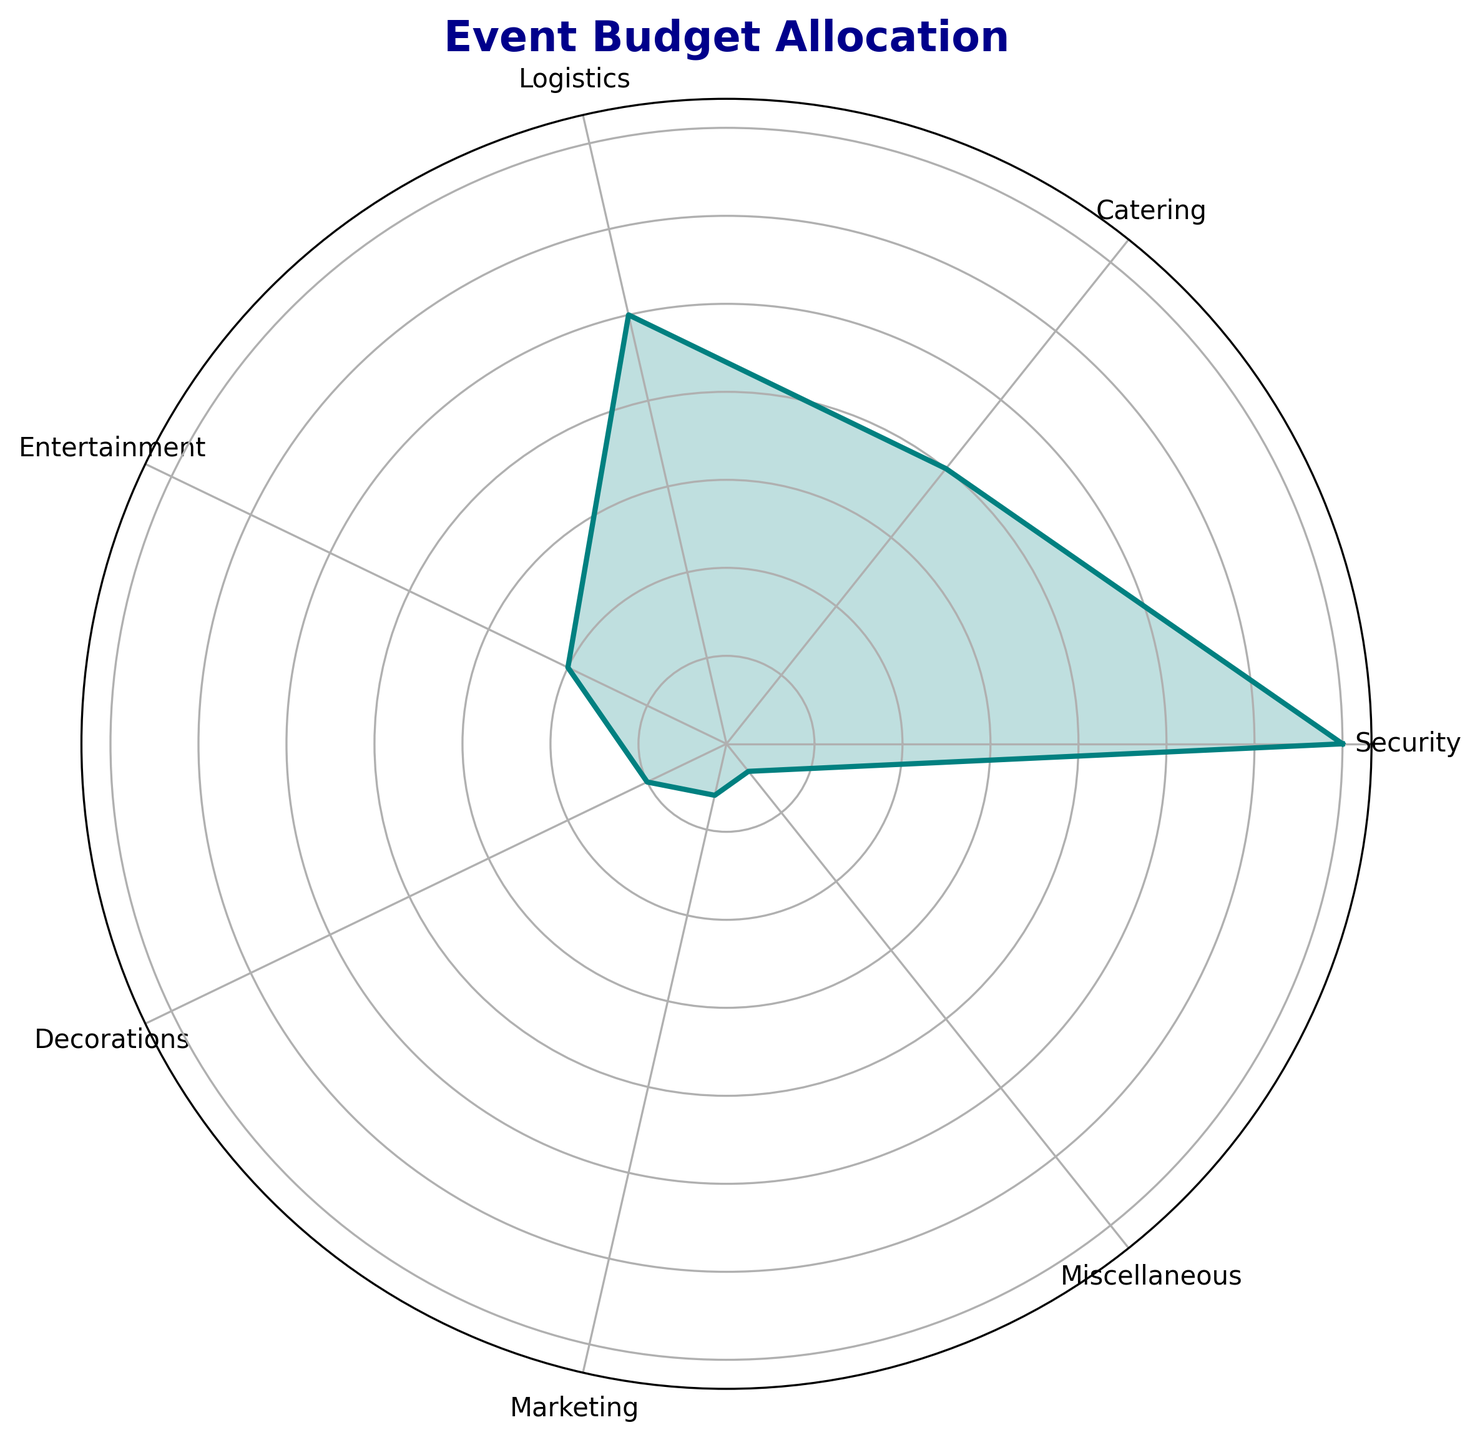Which category has the highest event budget allocation? By examining the lengths of the segments on the rose chart, the "Security" category is visually the longest, indicating the highest allocation of 35%.
Answer: Security What is the combined budget allocation percentage for Catering and Logistics? Adding the allocations for "Catering" (20%) and "Logistics" (25%) results in a combined percentage of 20 + 25 = 45%.
Answer: 45% Which category has a smaller budget allocation than Entertainment but larger than Miscellaneous? From the rose chart, "Decorations" has 5%, which is smaller than "Entertainment" (10%) but larger than "Miscellaneous" (2%).
Answer: Decorations How does the budget allocation for Marketing compare to that for Miscellaneous? "Marketing" has 3%, and "Miscellaneous" has 2%. By comparing these values, "Marketing" has a larger allocation by 1%.
Answer: Marketing is larger If we combine the budget allocations for Entertainment, Decorations, Marketing, and Miscellaneous, what percentage of the total budget do they represent? Summing the allocations: Entertainment 10% + Decorations 5% + Marketing 3% + Miscellaneous 2% = 20%.
Answer: 20% Which two categories have the smallest budget allocations, and what are their values? By looking at the shorter segments, "Marketing" with 3% and "Miscellaneous" with 2% are the smallest allocations.
Answer: Marketing: 3%, Miscellaneous: 2% How much more is allocated to Logistics compared to Catering? The allocation for "Logistics" is 25%, and for "Catering" it's 20%. The difference is 25% - 20% = 5%.
Answer: 5% What is the average budget allocation percentage for Security, Catering, and Logistics? Adding the allocations: Security (35%) + Catering (20%) + Logistics (25%) = 80%. Dividing by 3: 80% / 3 ≈ 26.67%.
Answer: 26.67% What percentage of the budget is allocated to categories other than Security? Subtracting Security's allocation (35%) from the total: 100% - 35% = 65%.
Answer: 65% 